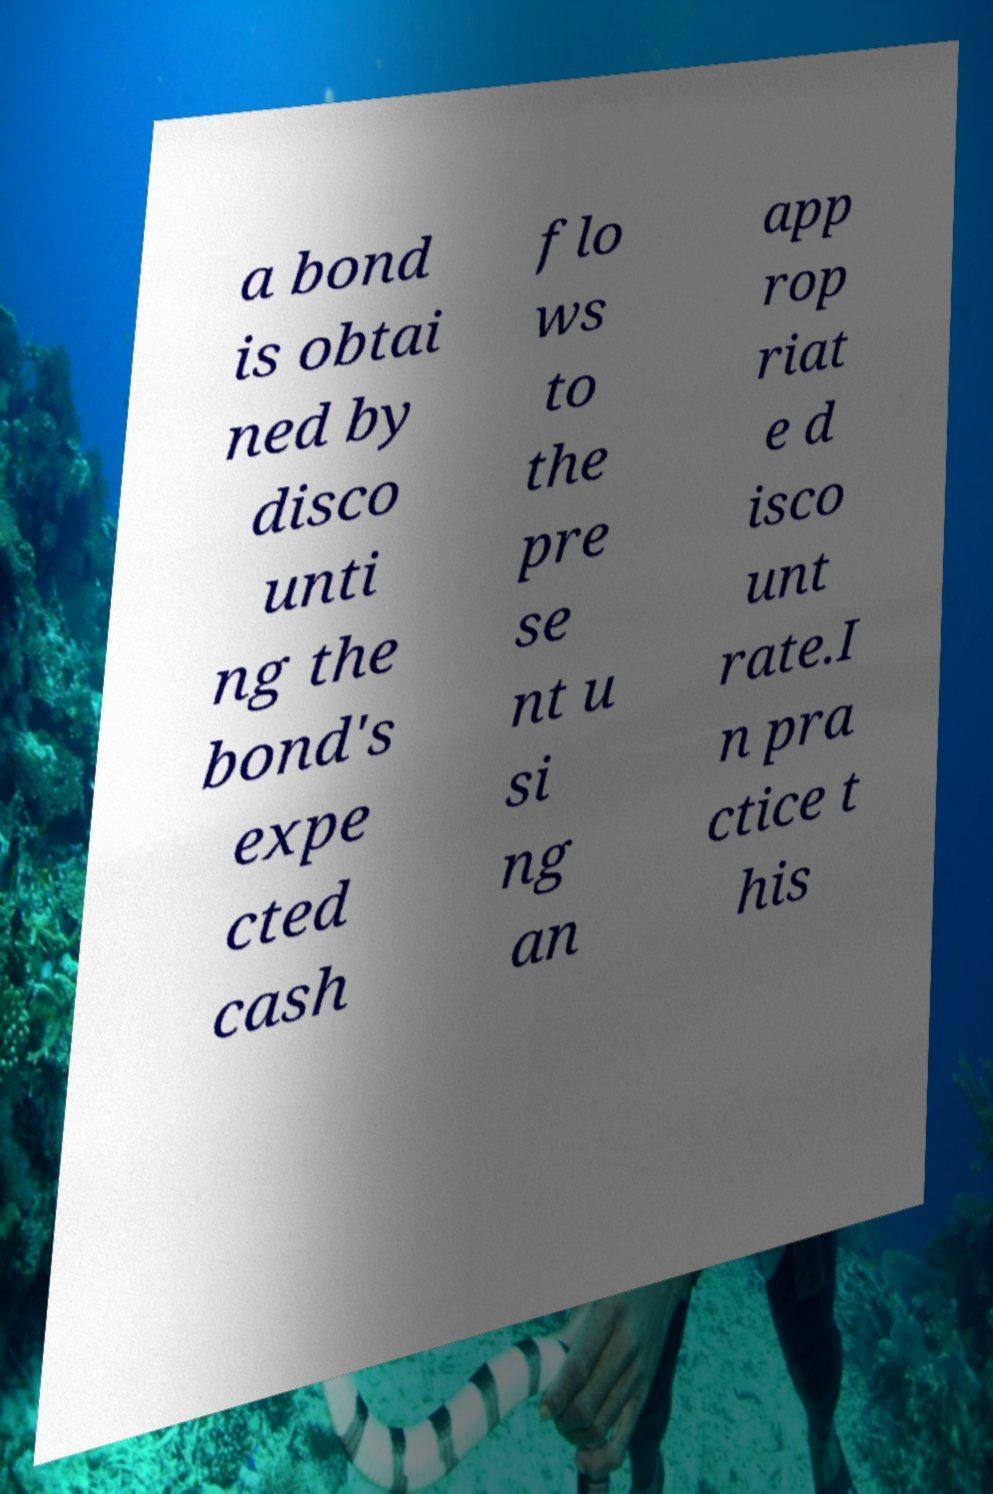For documentation purposes, I need the text within this image transcribed. Could you provide that? a bond is obtai ned by disco unti ng the bond's expe cted cash flo ws to the pre se nt u si ng an app rop riat e d isco unt rate.I n pra ctice t his 